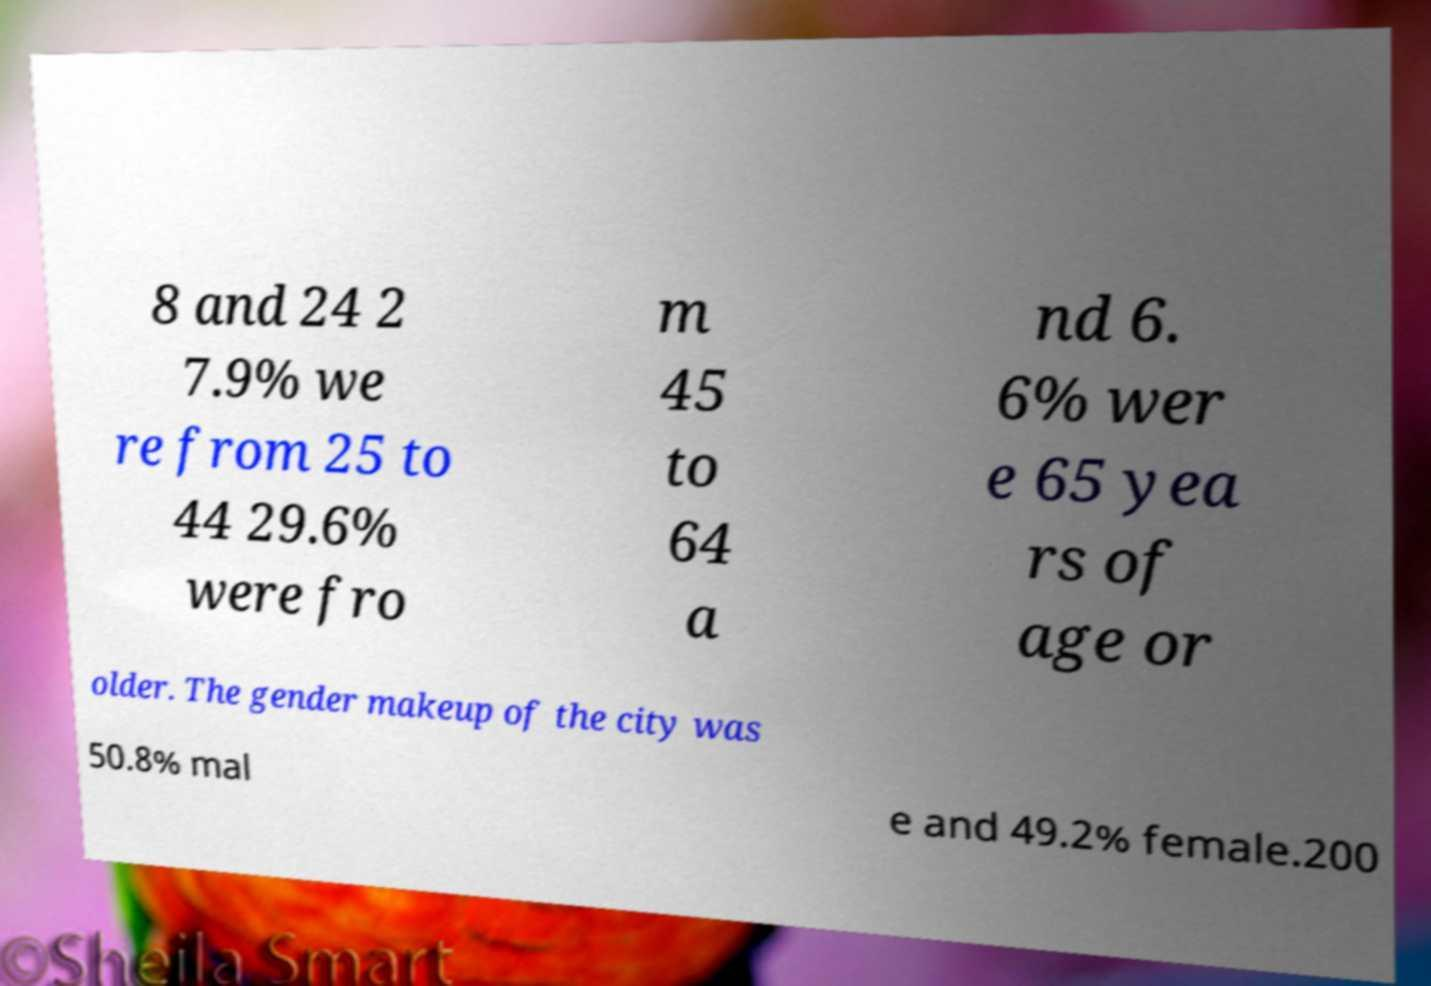There's text embedded in this image that I need extracted. Can you transcribe it verbatim? 8 and 24 2 7.9% we re from 25 to 44 29.6% were fro m 45 to 64 a nd 6. 6% wer e 65 yea rs of age or older. The gender makeup of the city was 50.8% mal e and 49.2% female.200 